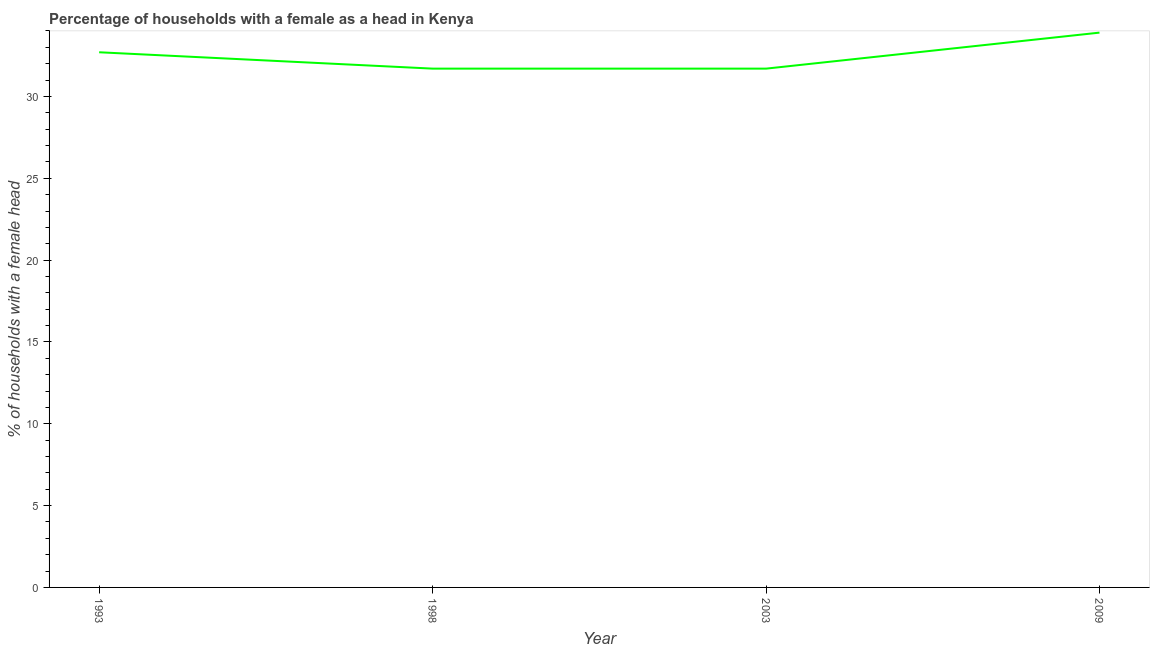What is the number of female supervised households in 2003?
Ensure brevity in your answer.  31.7. Across all years, what is the maximum number of female supervised households?
Your answer should be very brief. 33.9. Across all years, what is the minimum number of female supervised households?
Your response must be concise. 31.7. In which year was the number of female supervised households maximum?
Provide a succinct answer. 2009. In which year was the number of female supervised households minimum?
Provide a short and direct response. 1998. What is the sum of the number of female supervised households?
Make the answer very short. 130. What is the difference between the number of female supervised households in 1998 and 2009?
Provide a short and direct response. -2.2. What is the average number of female supervised households per year?
Provide a short and direct response. 32.5. What is the median number of female supervised households?
Make the answer very short. 32.2. What is the ratio of the number of female supervised households in 1993 to that in 2003?
Ensure brevity in your answer.  1.03. Is the difference between the number of female supervised households in 1998 and 2003 greater than the difference between any two years?
Your response must be concise. No. What is the difference between the highest and the second highest number of female supervised households?
Make the answer very short. 1.2. Is the sum of the number of female supervised households in 2003 and 2009 greater than the maximum number of female supervised households across all years?
Ensure brevity in your answer.  Yes. What is the difference between the highest and the lowest number of female supervised households?
Keep it short and to the point. 2.2. Does the number of female supervised households monotonically increase over the years?
Your answer should be compact. No. How many years are there in the graph?
Your answer should be compact. 4. Are the values on the major ticks of Y-axis written in scientific E-notation?
Ensure brevity in your answer.  No. Does the graph contain grids?
Offer a terse response. No. What is the title of the graph?
Your response must be concise. Percentage of households with a female as a head in Kenya. What is the label or title of the Y-axis?
Make the answer very short. % of households with a female head. What is the % of households with a female head of 1993?
Provide a succinct answer. 32.7. What is the % of households with a female head of 1998?
Give a very brief answer. 31.7. What is the % of households with a female head in 2003?
Give a very brief answer. 31.7. What is the % of households with a female head in 2009?
Make the answer very short. 33.9. What is the difference between the % of households with a female head in 1993 and 2009?
Ensure brevity in your answer.  -1.2. What is the difference between the % of households with a female head in 1998 and 2003?
Make the answer very short. 0. What is the difference between the % of households with a female head in 1998 and 2009?
Your response must be concise. -2.2. What is the difference between the % of households with a female head in 2003 and 2009?
Give a very brief answer. -2.2. What is the ratio of the % of households with a female head in 1993 to that in 1998?
Your answer should be compact. 1.03. What is the ratio of the % of households with a female head in 1993 to that in 2003?
Offer a very short reply. 1.03. What is the ratio of the % of households with a female head in 1998 to that in 2009?
Your answer should be compact. 0.94. What is the ratio of the % of households with a female head in 2003 to that in 2009?
Provide a short and direct response. 0.94. 